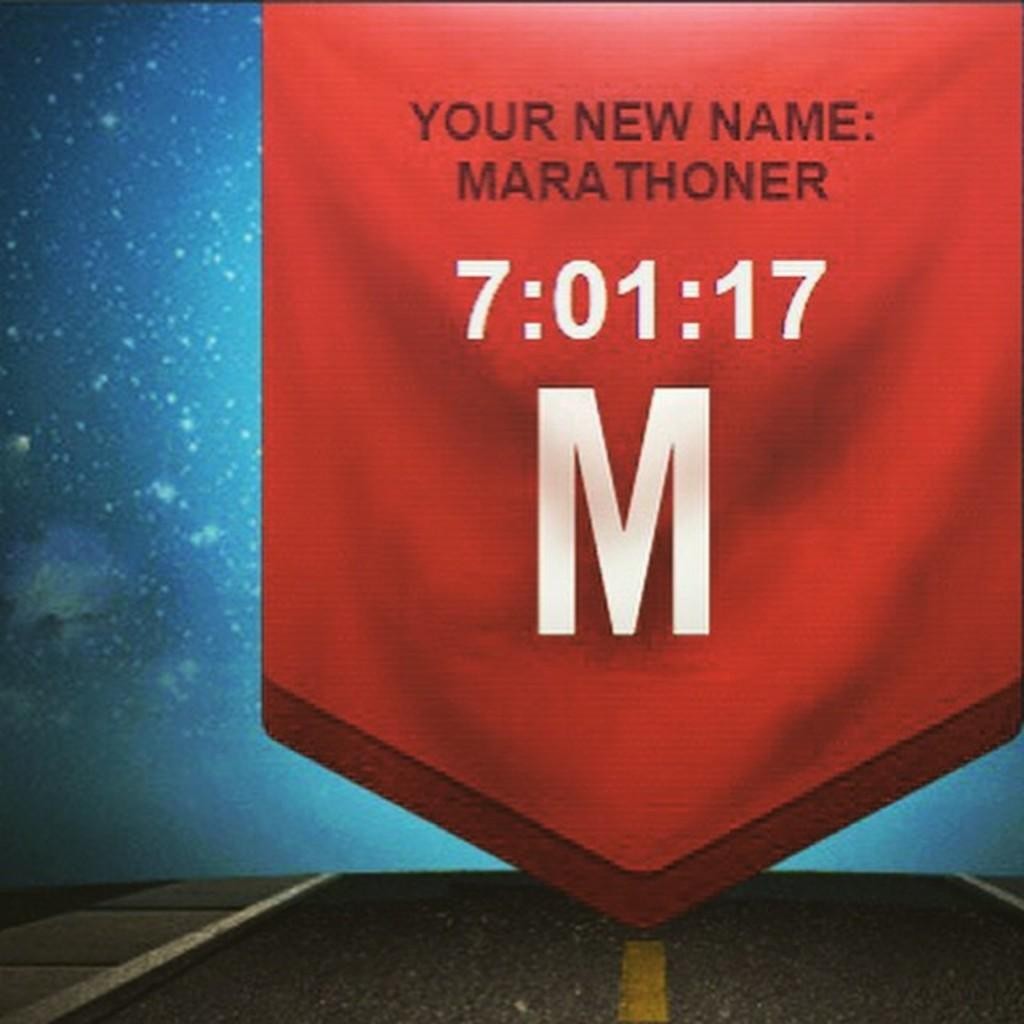What is the main subject in the center of the image? There is a flag in the center of the image. What can be seen at the bottom of the image? There is a road at the bottom of the image. What color is the background of the image? The background of the image is blue. How many thumbs are visible on the flag in the image? There are no thumbs visible on the flag in the image, as it is a flag and not a hand. Can you see any ants crawling on the road in the image? There are no ants visible on the road in the image. 